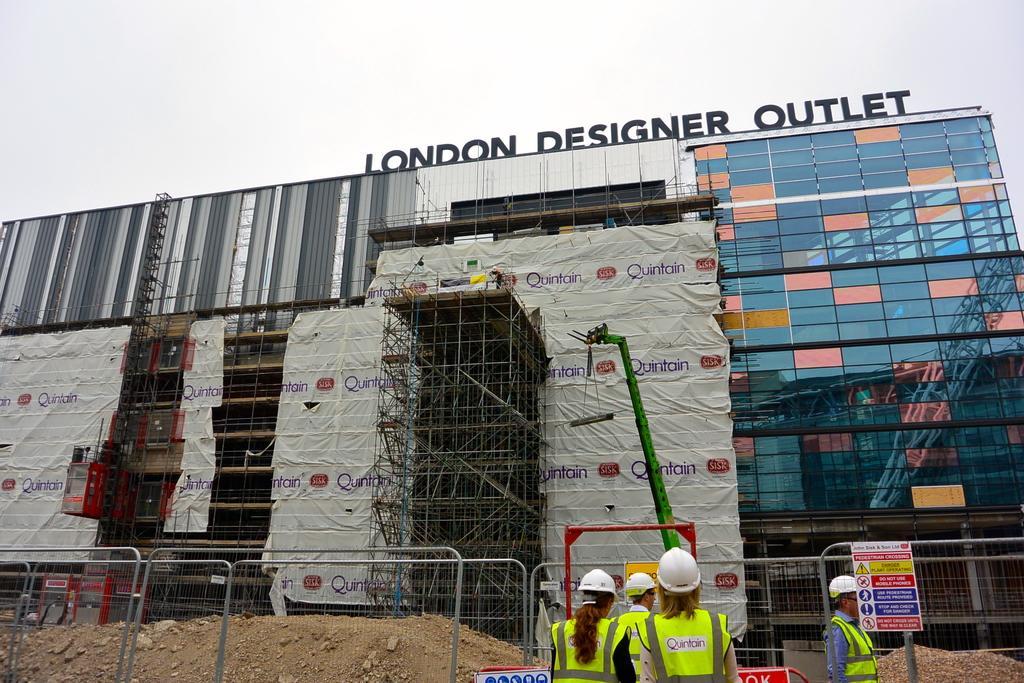In one or two sentences, can you explain what this image depicts? In this image I can see there is a building and it is under construction and there are a few people standing at the railing. The sky is clear. 